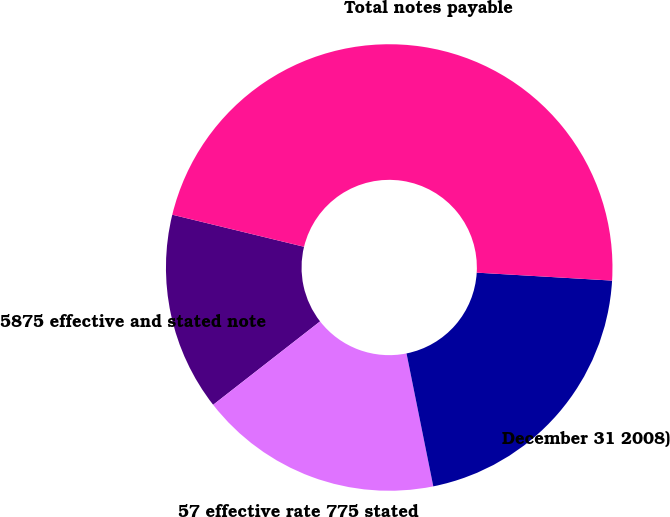Convert chart to OTSL. <chart><loc_0><loc_0><loc_500><loc_500><pie_chart><fcel>5875 effective and stated note<fcel>57 effective rate 775 stated<fcel>December 31 2008)<fcel>Total notes payable<nl><fcel>14.34%<fcel>17.62%<fcel>20.9%<fcel>47.13%<nl></chart> 